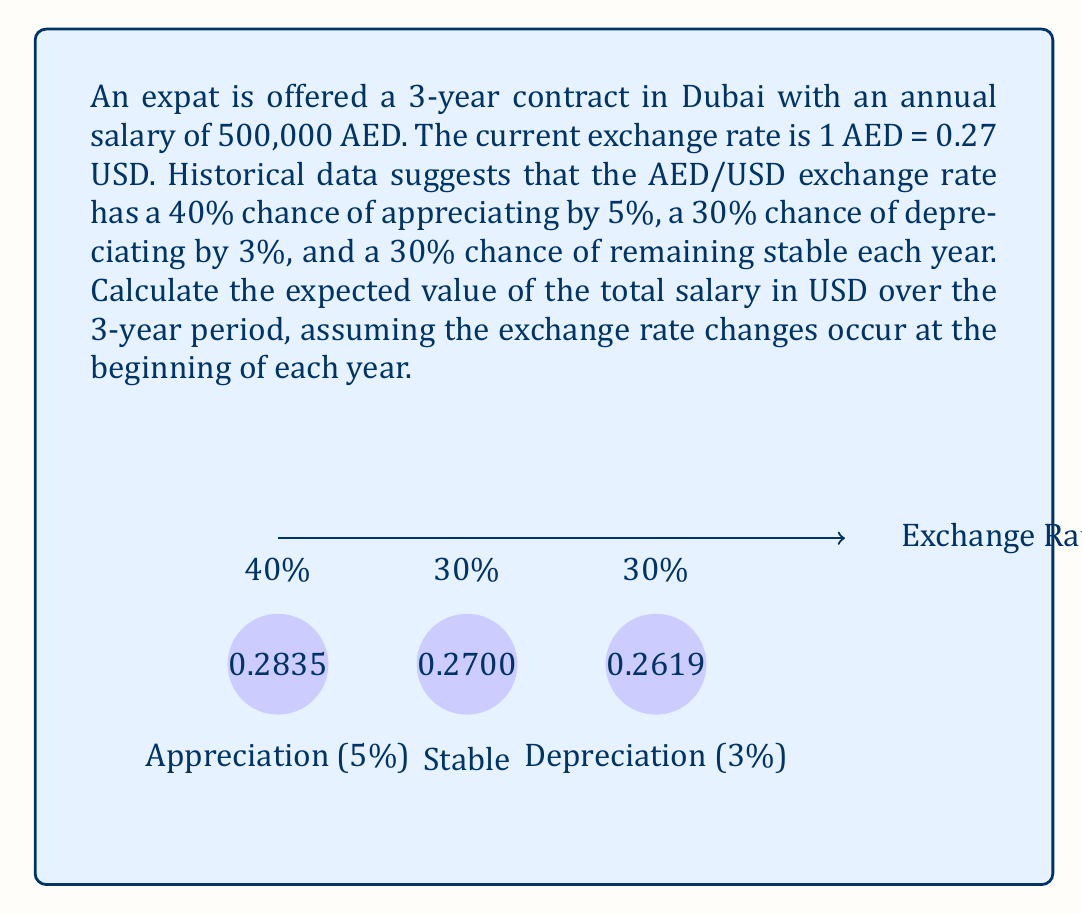Can you solve this math problem? Let's approach this problem step-by-step:

1) First, let's calculate the possible exchange rates for each year:
   - Appreciation: $0.27 \times 1.05 = 0.2835$
   - Stable: $0.27$
   - Depreciation: $0.27 \times 0.97 = 0.2619$

2) Now, let's calculate the salary in USD for each scenario:
   $500,000 \times 0.2835 = 141,750$ USD (Appreciation)
   $500,000 \times 0.27 = 135,000$ USD (Stable)
   $500,000 \times 0.2619 = 130,950$ USD (Depreciation)

3) The expected value for one year is:
   $E = (141,750 \times 0.4) + (135,000 \times 0.3) + (130,950 \times 0.3)$
   $E = 56,700 + 40,500 + 39,285 = 136,485$ USD

4) For a 3-year period, we need to consider all possible combinations. However, since the expected value is linear, we can multiply the yearly expected value by 3:

   $E_{total} = 136,485 \times 3 = 409,455$ USD

Therefore, the expected value of the total salary over the 3-year period is 409,455 USD.
Answer: $409,455 USD 